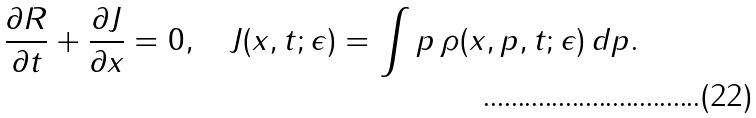Convert formula to latex. <formula><loc_0><loc_0><loc_500><loc_500>\frac { \partial R } { \partial t } + \frac { \partial J } { \partial x } = 0 , \quad J ( x , t ; \epsilon ) = \int p \, \rho ( x , p , t ; \epsilon ) \, d p .</formula> 